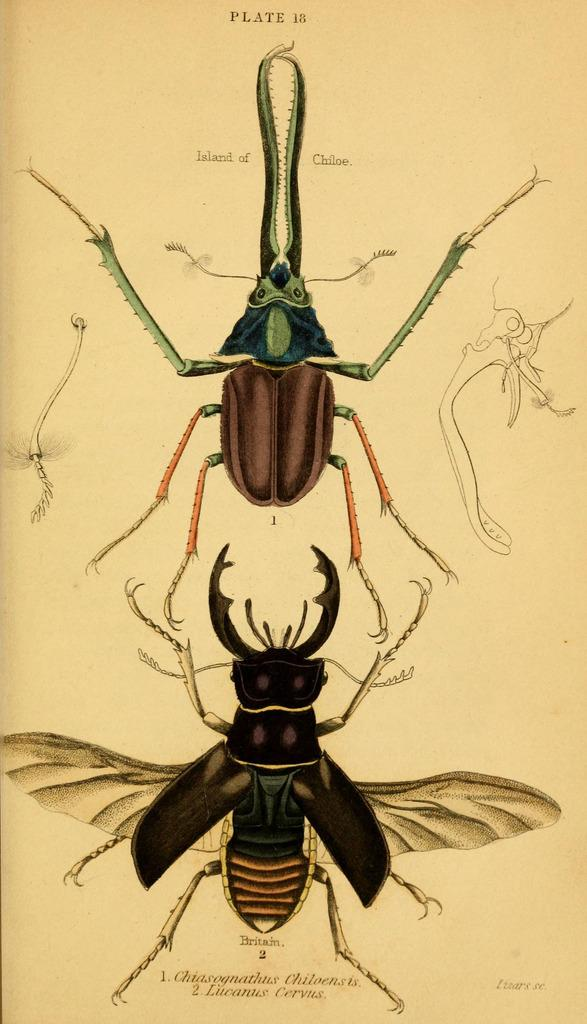How many beetles are present in the image? There are two beetles in the image. What are the colors of the beetles? One beetle is black, one is green, and one is brown. Can you describe the differences between the beetles? Yes, one beetle is black, one is green, and one is brown, indicating that they are of different colors. What type of rice is being cooked in the image? There is no rice present in the image; it features two beetles of different colors. 